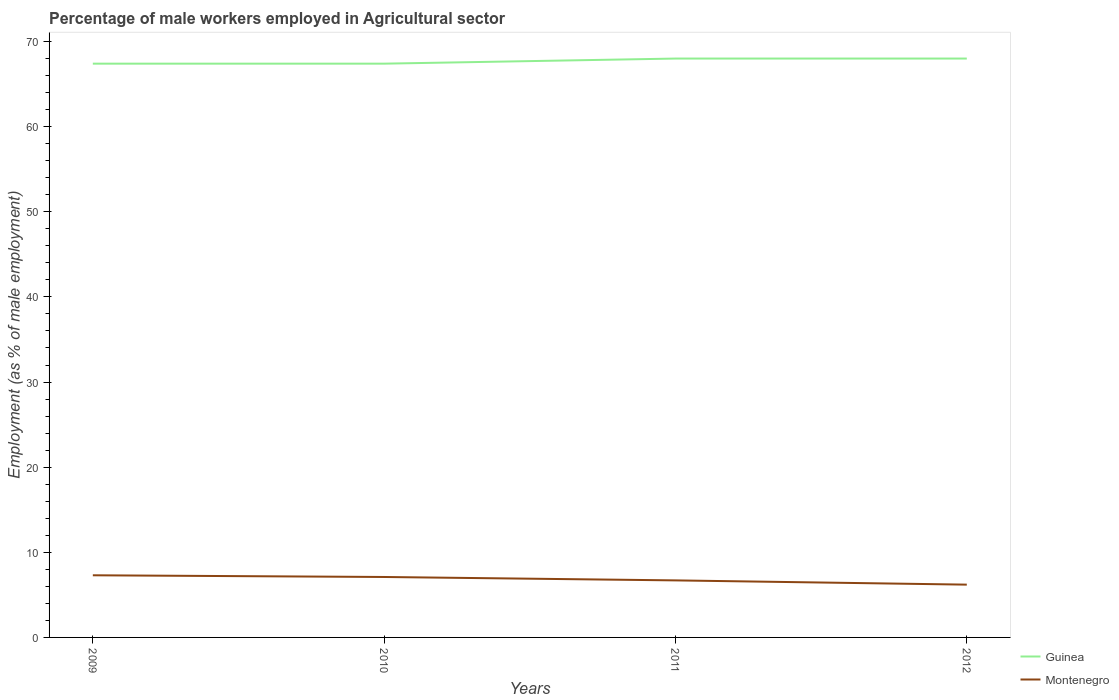How many different coloured lines are there?
Your response must be concise. 2. Across all years, what is the maximum percentage of male workers employed in Agricultural sector in Guinea?
Offer a terse response. 67.4. In which year was the percentage of male workers employed in Agricultural sector in Guinea maximum?
Make the answer very short. 2009. What is the total percentage of male workers employed in Agricultural sector in Guinea in the graph?
Your response must be concise. -0.6. What is the difference between the highest and the second highest percentage of male workers employed in Agricultural sector in Guinea?
Offer a very short reply. 0.6. What is the difference between the highest and the lowest percentage of male workers employed in Agricultural sector in Montenegro?
Make the answer very short. 2. Is the percentage of male workers employed in Agricultural sector in Guinea strictly greater than the percentage of male workers employed in Agricultural sector in Montenegro over the years?
Keep it short and to the point. No. How many lines are there?
Your response must be concise. 2. How many years are there in the graph?
Your answer should be compact. 4. Are the values on the major ticks of Y-axis written in scientific E-notation?
Offer a terse response. No. What is the title of the graph?
Your response must be concise. Percentage of male workers employed in Agricultural sector. Does "Slovenia" appear as one of the legend labels in the graph?
Offer a very short reply. No. What is the label or title of the Y-axis?
Your answer should be compact. Employment (as % of male employment). What is the Employment (as % of male employment) in Guinea in 2009?
Make the answer very short. 67.4. What is the Employment (as % of male employment) in Montenegro in 2009?
Ensure brevity in your answer.  7.3. What is the Employment (as % of male employment) of Guinea in 2010?
Your answer should be compact. 67.4. What is the Employment (as % of male employment) in Montenegro in 2010?
Your answer should be very brief. 7.1. What is the Employment (as % of male employment) in Guinea in 2011?
Provide a short and direct response. 68. What is the Employment (as % of male employment) of Montenegro in 2011?
Make the answer very short. 6.7. What is the Employment (as % of male employment) of Guinea in 2012?
Give a very brief answer. 68. What is the Employment (as % of male employment) in Montenegro in 2012?
Your answer should be compact. 6.2. Across all years, what is the maximum Employment (as % of male employment) of Montenegro?
Your answer should be very brief. 7.3. Across all years, what is the minimum Employment (as % of male employment) of Guinea?
Provide a succinct answer. 67.4. Across all years, what is the minimum Employment (as % of male employment) in Montenegro?
Your answer should be compact. 6.2. What is the total Employment (as % of male employment) in Guinea in the graph?
Provide a short and direct response. 270.8. What is the total Employment (as % of male employment) of Montenegro in the graph?
Offer a very short reply. 27.3. What is the difference between the Employment (as % of male employment) of Guinea in 2009 and that in 2010?
Give a very brief answer. 0. What is the difference between the Employment (as % of male employment) in Montenegro in 2009 and that in 2011?
Give a very brief answer. 0.6. What is the difference between the Employment (as % of male employment) in Montenegro in 2009 and that in 2012?
Provide a succinct answer. 1.1. What is the difference between the Employment (as % of male employment) of Montenegro in 2010 and that in 2011?
Ensure brevity in your answer.  0.4. What is the difference between the Employment (as % of male employment) in Montenegro in 2010 and that in 2012?
Provide a succinct answer. 0.9. What is the difference between the Employment (as % of male employment) of Guinea in 2011 and that in 2012?
Your answer should be very brief. 0. What is the difference between the Employment (as % of male employment) in Guinea in 2009 and the Employment (as % of male employment) in Montenegro in 2010?
Make the answer very short. 60.3. What is the difference between the Employment (as % of male employment) of Guinea in 2009 and the Employment (as % of male employment) of Montenegro in 2011?
Offer a terse response. 60.7. What is the difference between the Employment (as % of male employment) of Guinea in 2009 and the Employment (as % of male employment) of Montenegro in 2012?
Keep it short and to the point. 61.2. What is the difference between the Employment (as % of male employment) in Guinea in 2010 and the Employment (as % of male employment) in Montenegro in 2011?
Offer a terse response. 60.7. What is the difference between the Employment (as % of male employment) in Guinea in 2010 and the Employment (as % of male employment) in Montenegro in 2012?
Ensure brevity in your answer.  61.2. What is the difference between the Employment (as % of male employment) of Guinea in 2011 and the Employment (as % of male employment) of Montenegro in 2012?
Provide a short and direct response. 61.8. What is the average Employment (as % of male employment) in Guinea per year?
Ensure brevity in your answer.  67.7. What is the average Employment (as % of male employment) in Montenegro per year?
Make the answer very short. 6.83. In the year 2009, what is the difference between the Employment (as % of male employment) of Guinea and Employment (as % of male employment) of Montenegro?
Ensure brevity in your answer.  60.1. In the year 2010, what is the difference between the Employment (as % of male employment) in Guinea and Employment (as % of male employment) in Montenegro?
Provide a short and direct response. 60.3. In the year 2011, what is the difference between the Employment (as % of male employment) in Guinea and Employment (as % of male employment) in Montenegro?
Make the answer very short. 61.3. In the year 2012, what is the difference between the Employment (as % of male employment) in Guinea and Employment (as % of male employment) in Montenegro?
Provide a succinct answer. 61.8. What is the ratio of the Employment (as % of male employment) in Guinea in 2009 to that in 2010?
Give a very brief answer. 1. What is the ratio of the Employment (as % of male employment) in Montenegro in 2009 to that in 2010?
Ensure brevity in your answer.  1.03. What is the ratio of the Employment (as % of male employment) of Montenegro in 2009 to that in 2011?
Ensure brevity in your answer.  1.09. What is the ratio of the Employment (as % of male employment) of Montenegro in 2009 to that in 2012?
Your answer should be compact. 1.18. What is the ratio of the Employment (as % of male employment) in Guinea in 2010 to that in 2011?
Offer a terse response. 0.99. What is the ratio of the Employment (as % of male employment) of Montenegro in 2010 to that in 2011?
Provide a succinct answer. 1.06. What is the ratio of the Employment (as % of male employment) of Montenegro in 2010 to that in 2012?
Your response must be concise. 1.15. What is the ratio of the Employment (as % of male employment) of Montenegro in 2011 to that in 2012?
Ensure brevity in your answer.  1.08. What is the difference between the highest and the second highest Employment (as % of male employment) in Guinea?
Give a very brief answer. 0. 